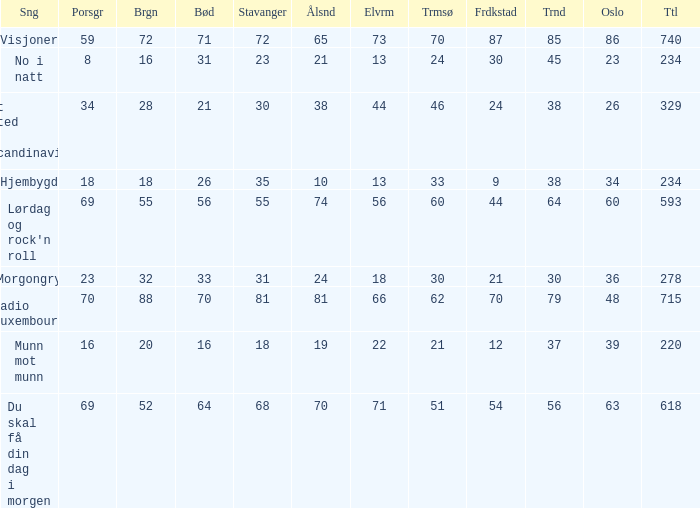When oslo is 48, what is stavanger? 81.0. 